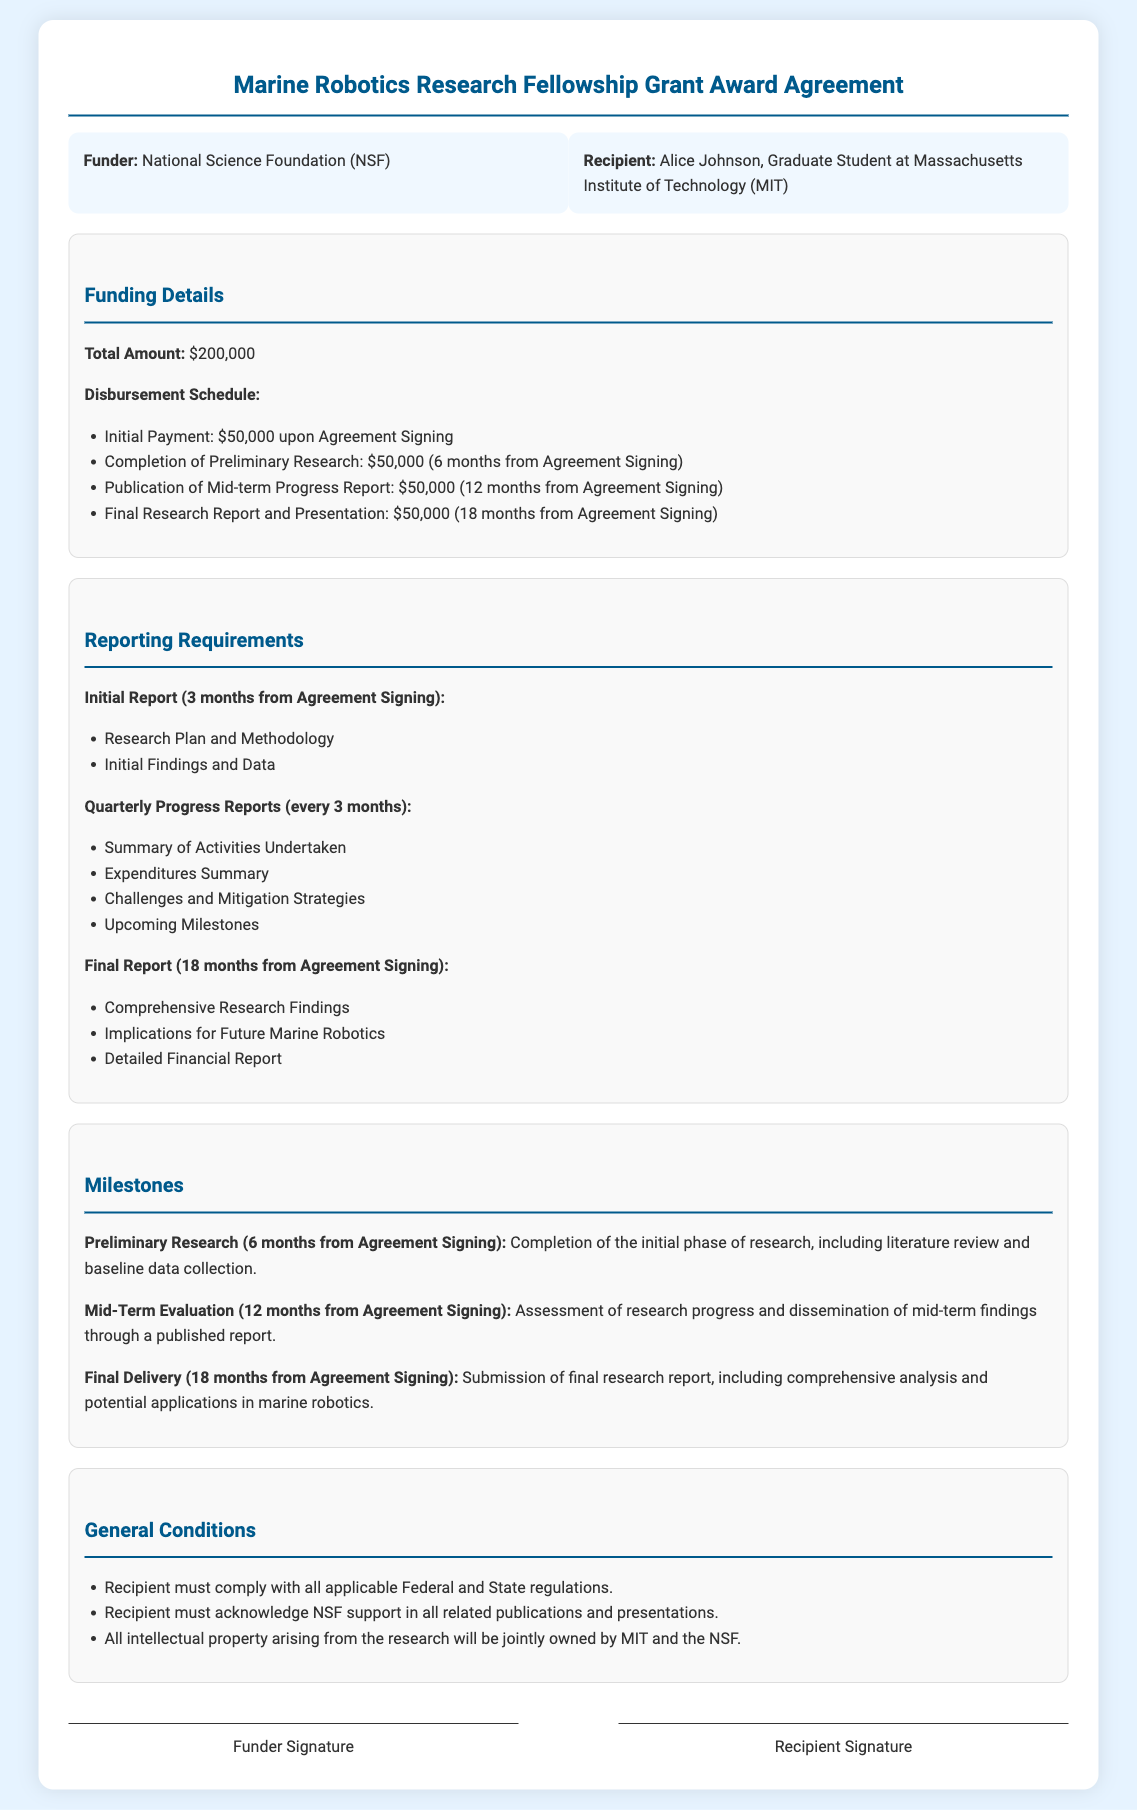What is the total amount of funding? The total amount of funding detailed in the document is presented in the Funding Details section as $200,000.
Answer: $200,000 Who is the recipient of the grant? The recipient of the grant is specified in the Parties section as Alice Johnson, Graduate Student at Massachusetts Institute of Technology (MIT).
Answer: Alice Johnson When is the initial payment due? The disbursement schedule indicates that the initial payment is due upon Agreement Signing, which is the first payment milestone.
Answer: Upon Agreement Signing What are the contents of the Initial Report? The Initial Report requirements include key components as outlined in the Reporting Requirements section: Research Plan and Methodology and Initial Findings and Data.
Answer: Research Plan and Methodology, Initial Findings and Data What is the milestone due in 12 months? The document specifies that the Mid-Term Evaluation, which involves assessment of research progress and dissemination of mid-term findings through a published report, is due 12 months from the agreement signing.
Answer: Mid-Term Evaluation What must the recipient acknowledge in publications? The General Conditions section states that the recipient must acknowledge NSF support in all related publications and presentations.
Answer: NSF support What is the final report deadline? The final report is specified to be due 18 months from the Agreement Signing, as noted in the Reporting Requirements section.
Answer: 18 months from Agreement Signing What is the total number of progress reports required? According to the Reporting Requirements, there are quarterly progress reports required every 3 months, resulting in a total of 6 reports in an 18-month period.
Answer: 6 reports 